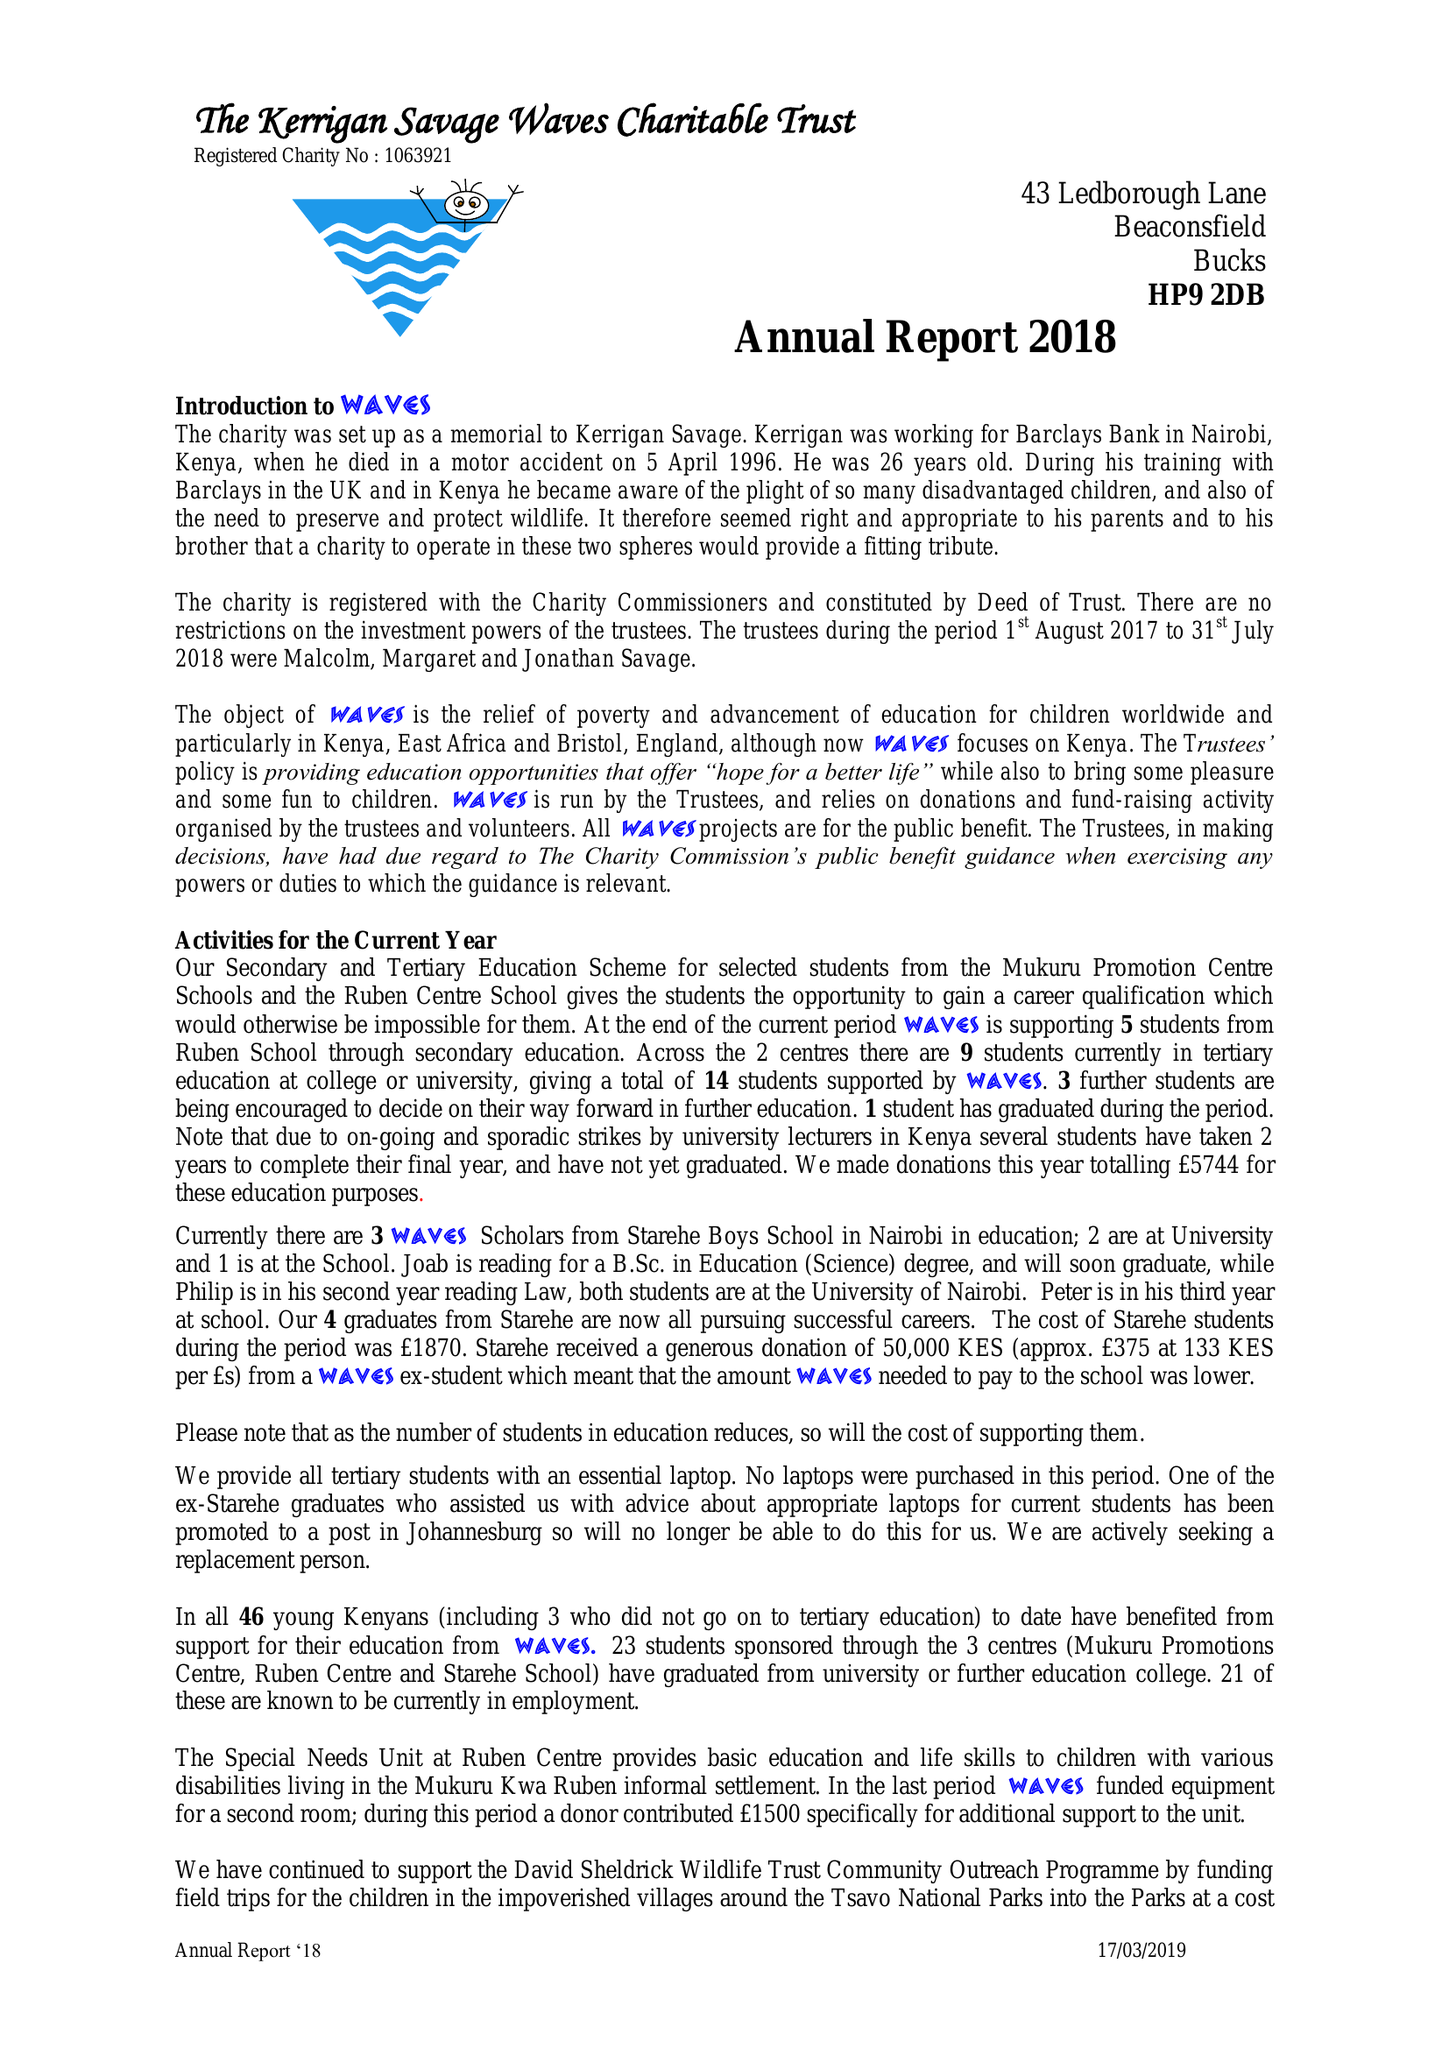What is the value for the spending_annually_in_british_pounds?
Answer the question using a single word or phrase. 27221.00 